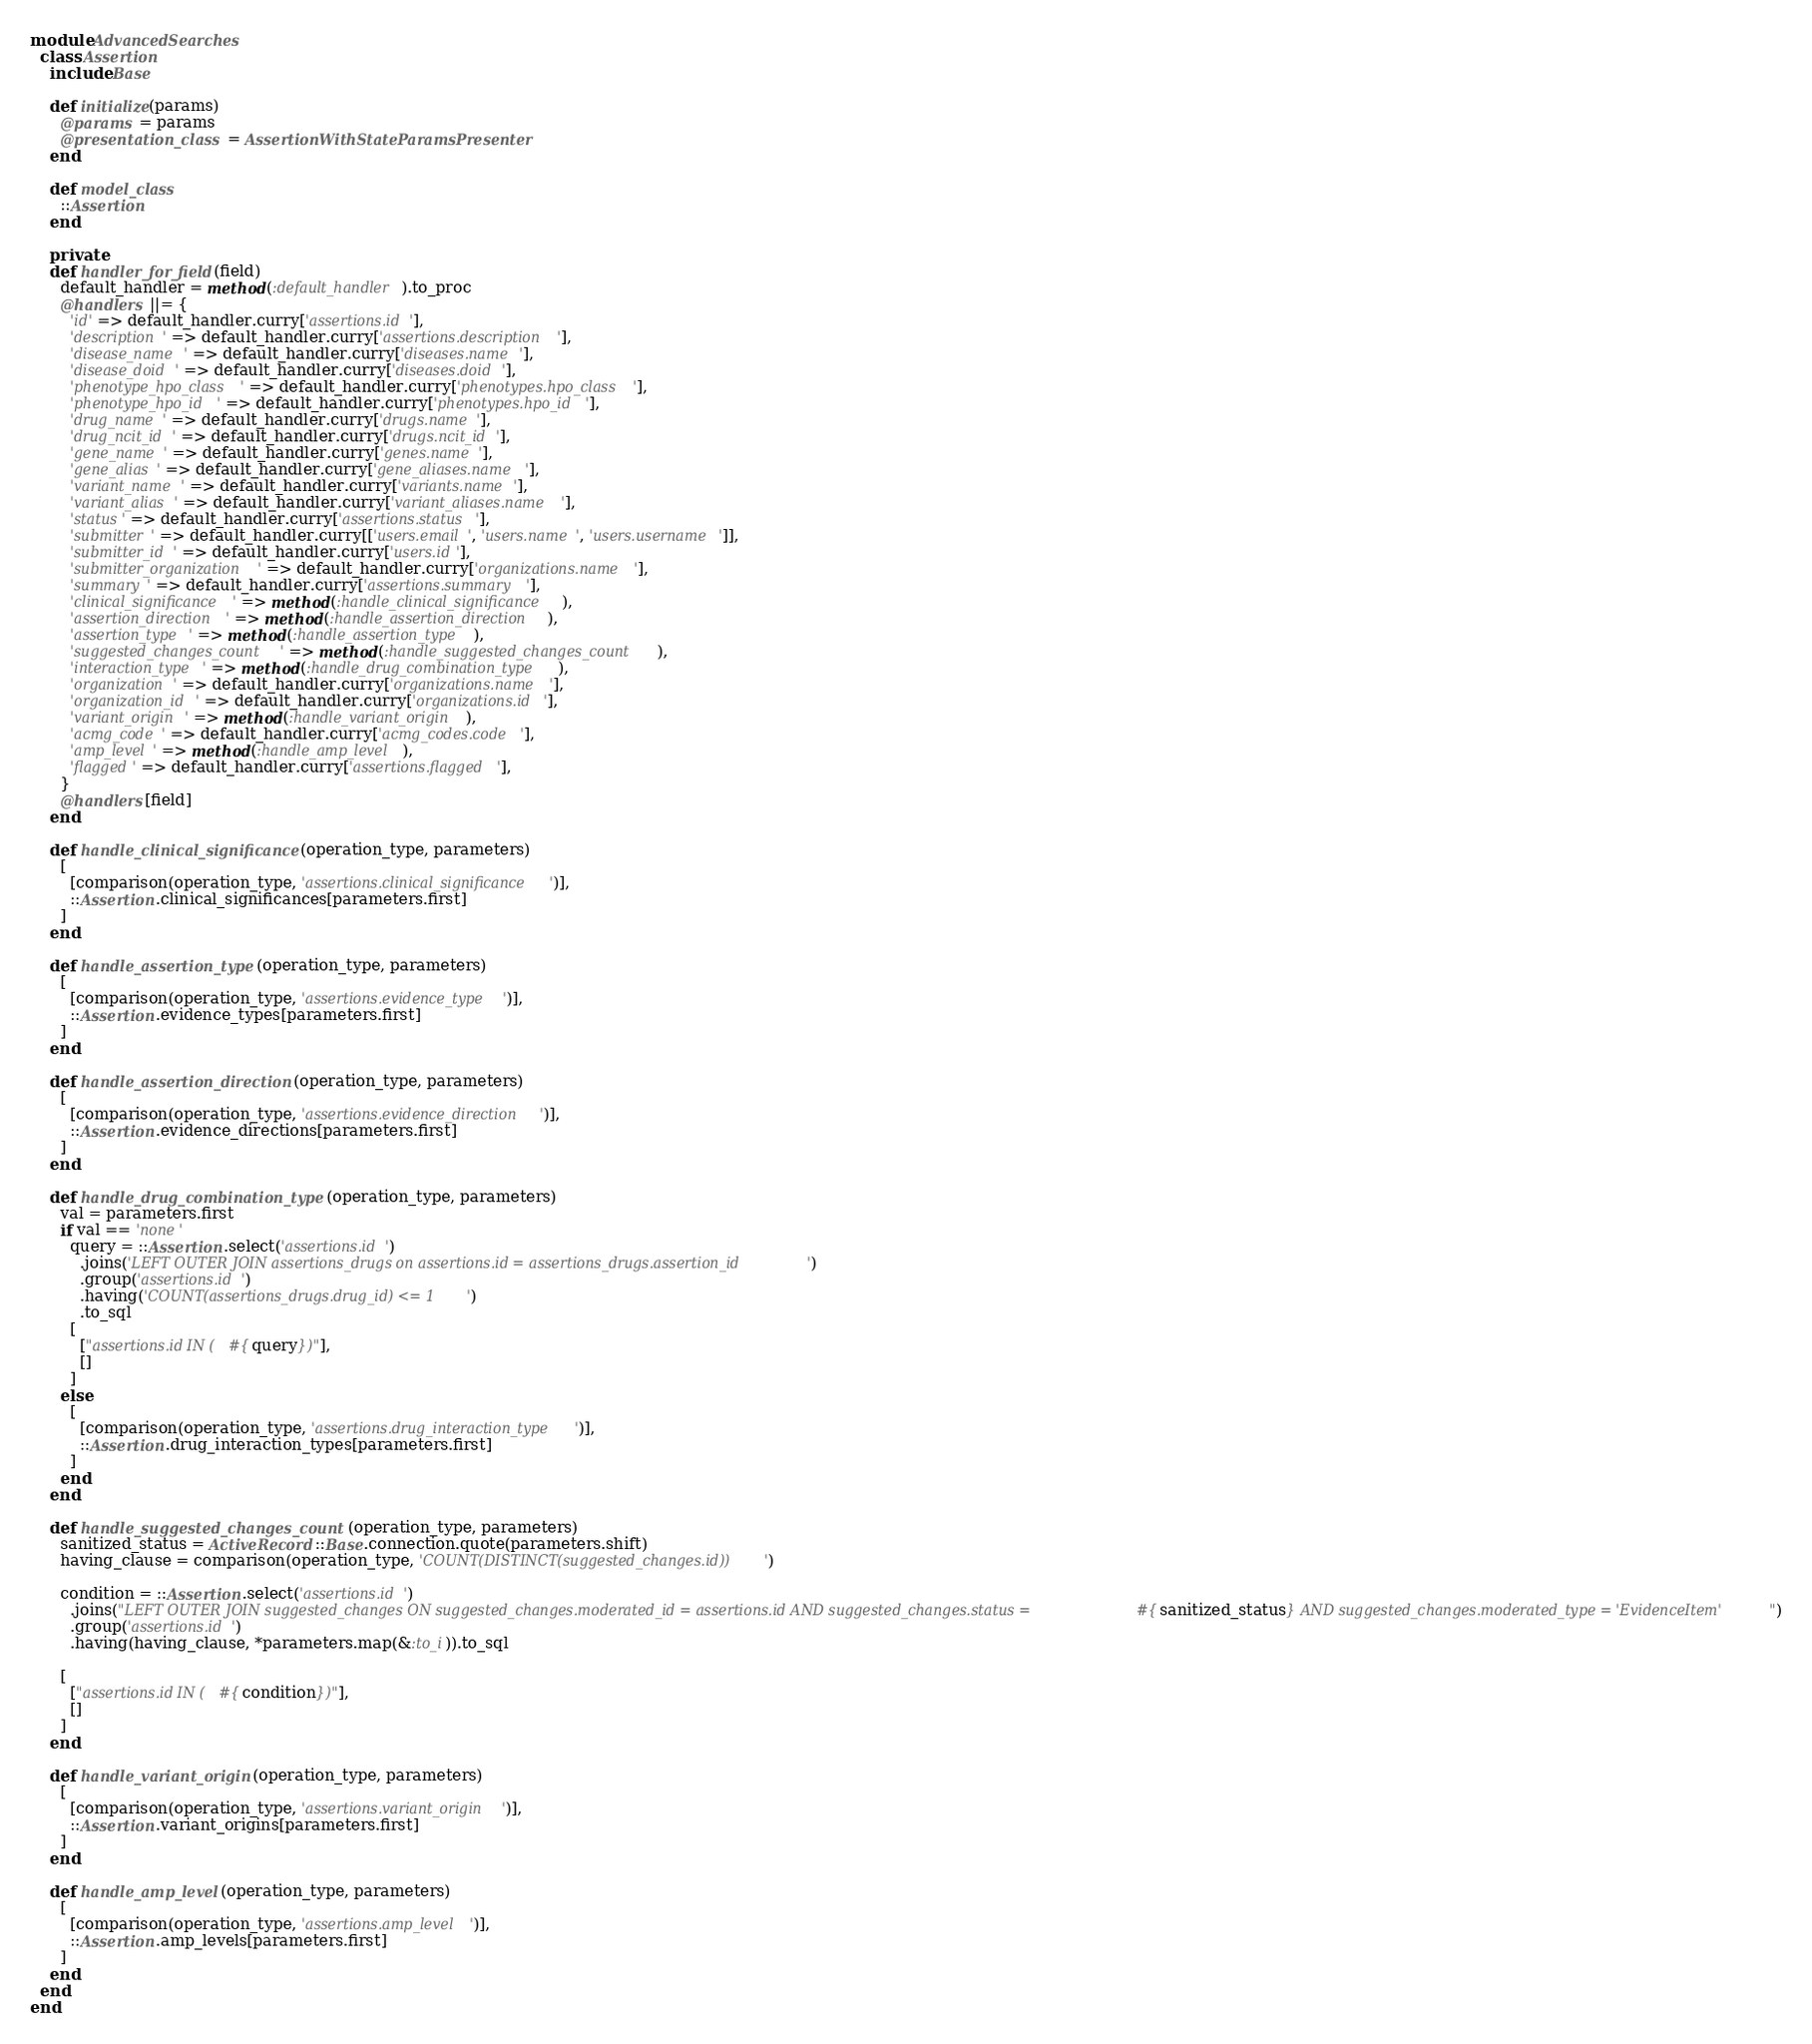Convert code to text. <code><loc_0><loc_0><loc_500><loc_500><_Ruby_>module AdvancedSearches
  class Assertion
    include Base

    def initialize(params)
      @params = params
      @presentation_class = AssertionWithStateParamsPresenter
    end

    def model_class
      ::Assertion
    end

    private
    def handler_for_field(field)
      default_handler = method(:default_handler).to_proc
      @handlers ||= {
        'id' => default_handler.curry['assertions.id'],
        'description' => default_handler.curry['assertions.description'],
        'disease_name' => default_handler.curry['diseases.name'],
        'disease_doid' => default_handler.curry['diseases.doid'],
        'phenotype_hpo_class' => default_handler.curry['phenotypes.hpo_class'],
        'phenotype_hpo_id' => default_handler.curry['phenotypes.hpo_id'],
        'drug_name' => default_handler.curry['drugs.name'],
        'drug_ncit_id' => default_handler.curry['drugs.ncit_id'],
        'gene_name' => default_handler.curry['genes.name'],
        'gene_alias' => default_handler.curry['gene_aliases.name'],
        'variant_name' => default_handler.curry['variants.name'],
        'variant_alias' => default_handler.curry['variant_aliases.name'],
        'status' => default_handler.curry['assertions.status'],
        'submitter' => default_handler.curry[['users.email', 'users.name', 'users.username']],
        'submitter_id' => default_handler.curry['users.id'],
        'submitter_organization' => default_handler.curry['organizations.name'],
        'summary' => default_handler.curry['assertions.summary'],
        'clinical_significance' => method(:handle_clinical_significance),
        'assertion_direction' => method(:handle_assertion_direction),
        'assertion_type' => method(:handle_assertion_type),
        'suggested_changes_count' => method(:handle_suggested_changes_count),
        'interaction_type' => method(:handle_drug_combination_type),
        'organization' => default_handler.curry['organizations.name'],
        'organization_id' => default_handler.curry['organizations.id'],
        'variant_origin' => method(:handle_variant_origin),
        'acmg_code' => default_handler.curry['acmg_codes.code'],
        'amp_level' => method(:handle_amp_level),
        'flagged' => default_handler.curry['assertions.flagged'],
      }
      @handlers[field]
    end

    def handle_clinical_significance(operation_type, parameters)
      [
        [comparison(operation_type, 'assertions.clinical_significance')],
        ::Assertion.clinical_significances[parameters.first]
      ]
    end

    def handle_assertion_type(operation_type, parameters)
      [
        [comparison(operation_type, 'assertions.evidence_type')],
        ::Assertion.evidence_types[parameters.first]
      ]
    end

    def handle_assertion_direction(operation_type, parameters)
      [
        [comparison(operation_type, 'assertions.evidence_direction')],
        ::Assertion.evidence_directions[parameters.first]
      ]
    end

    def handle_drug_combination_type(operation_type, parameters)
      val = parameters.first
      if val == 'none'
        query = ::Assertion.select('assertions.id')
          .joins('LEFT OUTER JOIN assertions_drugs on assertions.id = assertions_drugs.assertion_id')
          .group('assertions.id')
          .having('COUNT(assertions_drugs.drug_id) <= 1')
          .to_sql
        [
          ["assertions.id IN (#{query})"],
          []
        ]
      else
        [
          [comparison(operation_type, 'assertions.drug_interaction_type')],
          ::Assertion.drug_interaction_types[parameters.first]
        ]
      end
    end

    def handle_suggested_changes_count(operation_type, parameters)
      sanitized_status = ActiveRecord::Base.connection.quote(parameters.shift)
      having_clause = comparison(operation_type, 'COUNT(DISTINCT(suggested_changes.id))')

      condition = ::Assertion.select('assertions.id')
        .joins("LEFT OUTER JOIN suggested_changes ON suggested_changes.moderated_id = assertions.id AND suggested_changes.status = #{sanitized_status} AND suggested_changes.moderated_type = 'EvidenceItem'")
        .group('assertions.id')
        .having(having_clause, *parameters.map(&:to_i)).to_sql

      [
        ["assertions.id IN (#{condition})"],
        []
      ]
    end

    def handle_variant_origin(operation_type, parameters)
      [
        [comparison(operation_type, 'assertions.variant_origin')],
        ::Assertion.variant_origins[parameters.first]
      ]
    end

    def handle_amp_level(operation_type, parameters)
      [
        [comparison(operation_type, 'assertions.amp_level')],
        ::Assertion.amp_levels[parameters.first]
      ]
    end
  end
end
</code> 